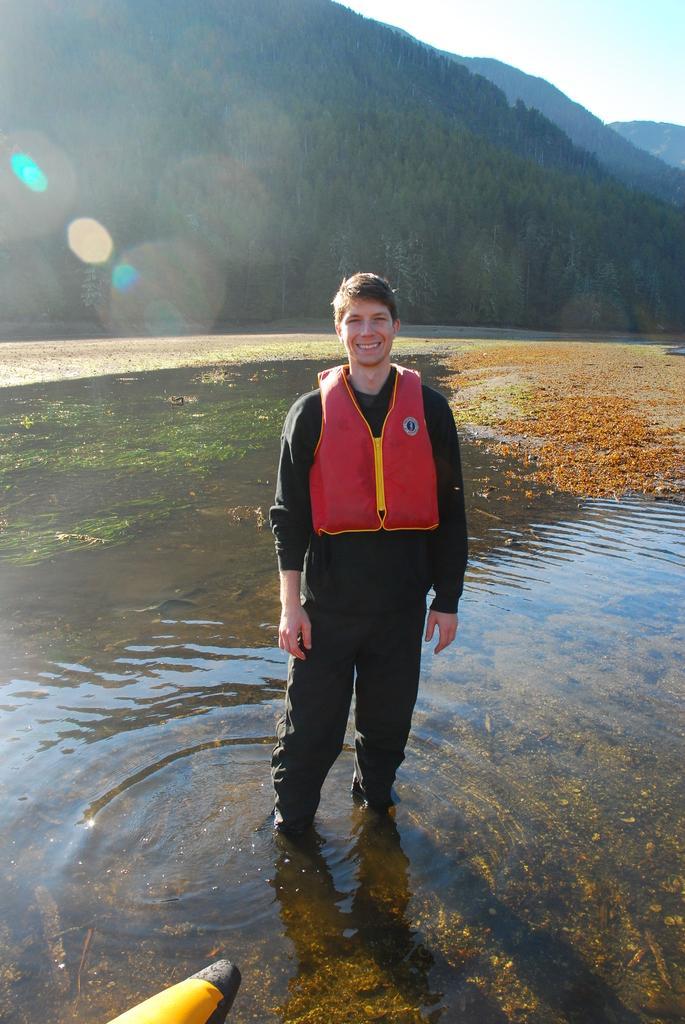Can you describe this image briefly? In this image in front there is a person standing in the water and he is wearing a smile on his face. In the background there are trees, mountains and sky. 